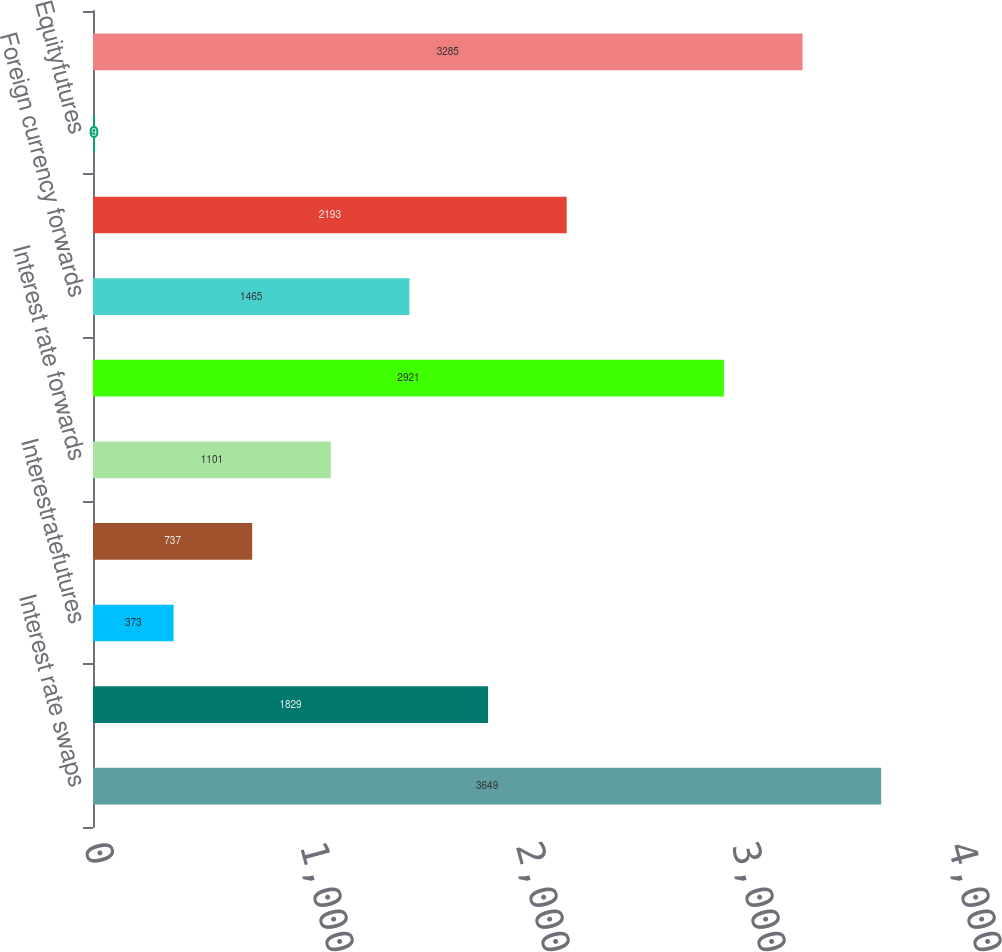Convert chart to OTSL. <chart><loc_0><loc_0><loc_500><loc_500><bar_chart><fcel>Interest rate swaps<fcel>Interest rate floors<fcel>Interestratefutures<fcel>Interest rate options<fcel>Interest rate forwards<fcel>Foreign currency swaps<fcel>Foreign currency forwards<fcel>Credit default swaps<fcel>Equityfutures<fcel>Equity options<nl><fcel>3649<fcel>1829<fcel>373<fcel>737<fcel>1101<fcel>2921<fcel>1465<fcel>2193<fcel>9<fcel>3285<nl></chart> 